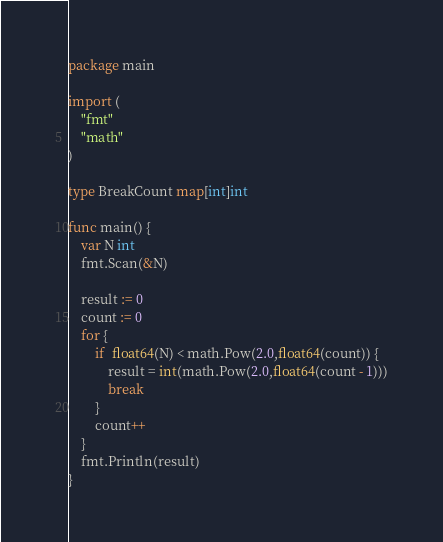<code> <loc_0><loc_0><loc_500><loc_500><_Go_>package main

import (
	"fmt"
	"math"
)

type BreakCount map[int]int

func main() {
	var N int
	fmt.Scan(&N)

	result := 0
	count := 0
	for {
		if  float64(N) < math.Pow(2.0,float64(count)) {
			result = int(math.Pow(2.0,float64(count - 1)))
			break
		}
		count++
	}
	fmt.Println(result)
}
</code> 